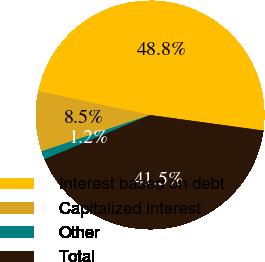Convert chart. <chart><loc_0><loc_0><loc_500><loc_500><pie_chart><fcel>Interest based on debt<fcel>Capitalized interest<fcel>Other<fcel>Total<nl><fcel>48.82%<fcel>8.49%<fcel>1.18%<fcel>41.51%<nl></chart> 